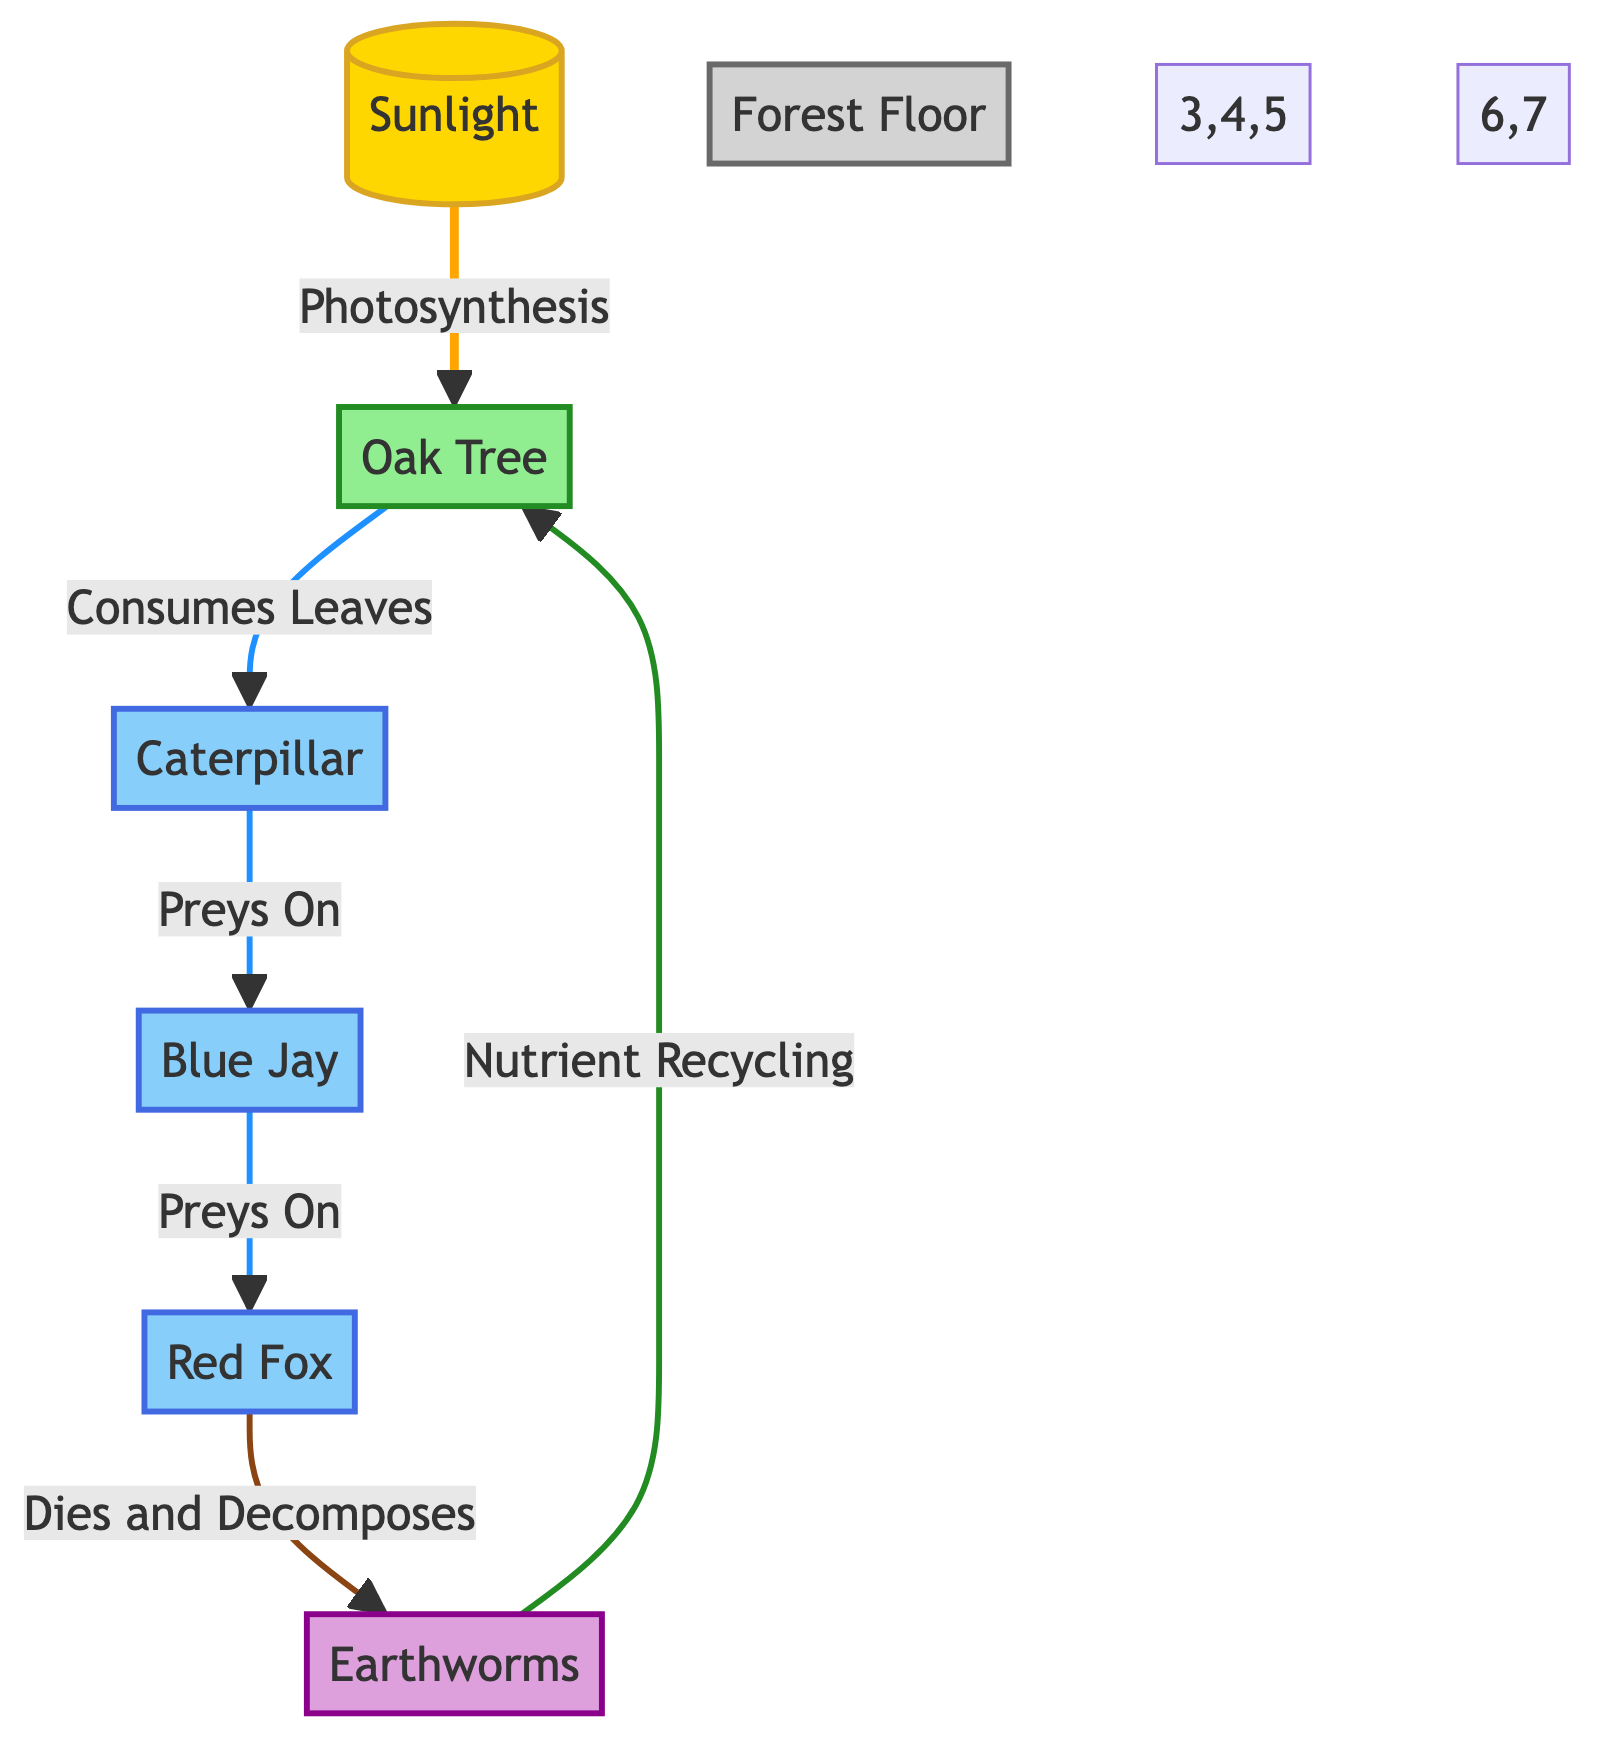What's the primary energy source in this ecosystem? The diagram indicates that the primary energy source is "Sunlight" as the node labeled "Sunlight" is the starting point from which all energy flows into the ecosystem.
Answer: Sunlight How many consumers are present in the diagram? By counting the nodes labeled as consumers in the diagram, we identify three: "Caterpillar," "Blue Jay," and "Red Fox." Therefore, the total number is three.
Answer: 3 What does the Oak Tree produce? The Oak Tree, as depicted in the diagram, is involved in the process of photosynthesis, converting sunlight into energy, which effectively makes it a producer in the ecosystem. It supports caterpillars by providing leaves for consumption.
Answer: Leaves What animal preys on the Caterpillar? The diagram shows that the Blue Jay, represented as a consumer, preys on the caterpillar as indicated by the connection from the caterpillar to the blue jay labeled "Preys On."
Answer: Blue Jay Which organism is responsible for nutrient recycling? The diagram indicates that Earthworms participate in nutrient cycling as they decompose organic matter, which is shown by the arrow leading from "Dies and Decomposes" to "Nutrient Recycling."
Answer: Earthworms How does energy flow from the Red Fox to the Oak Tree? Energy flows indirectly from the Red Fox back to the Oak Tree through the decomposition process. When the Red Fox dies, it is broken down by decomposers (Earthworms), and through this decomposition, nutrients are recycled back into the Oak Tree, classified as a producer.
Answer: Through decomposition (Earthworms) What is the role of the Earthworms in the ecosystem? Earthworms act as decomposers in this ecosystem, facilitating the nutrient recycling process. The diagram highlights their role by showing arrows leading from "Dies and Decomposes" to "Nutrient Recycling" and then to the Oak Tree, indicating their essential function in breaking down organic materials.
Answer: Decomposers Identify the relationship between Blue Jay and Red Fox. The diagram illustrates that the Blue Jay preys on the Caterpillar, and the Red Fox preys on the Blue Jay. Thus, the relationship is that the Blue Jay is a food source for the Red Fox.
Answer: Predation What is depicted as the environmental component in the ecosystem? The diagram includes "Forest Floor" as the environmental component, represented in gray and serving as a context for the ecosystem's interactions and relationships.
Answer: Forest Floor 